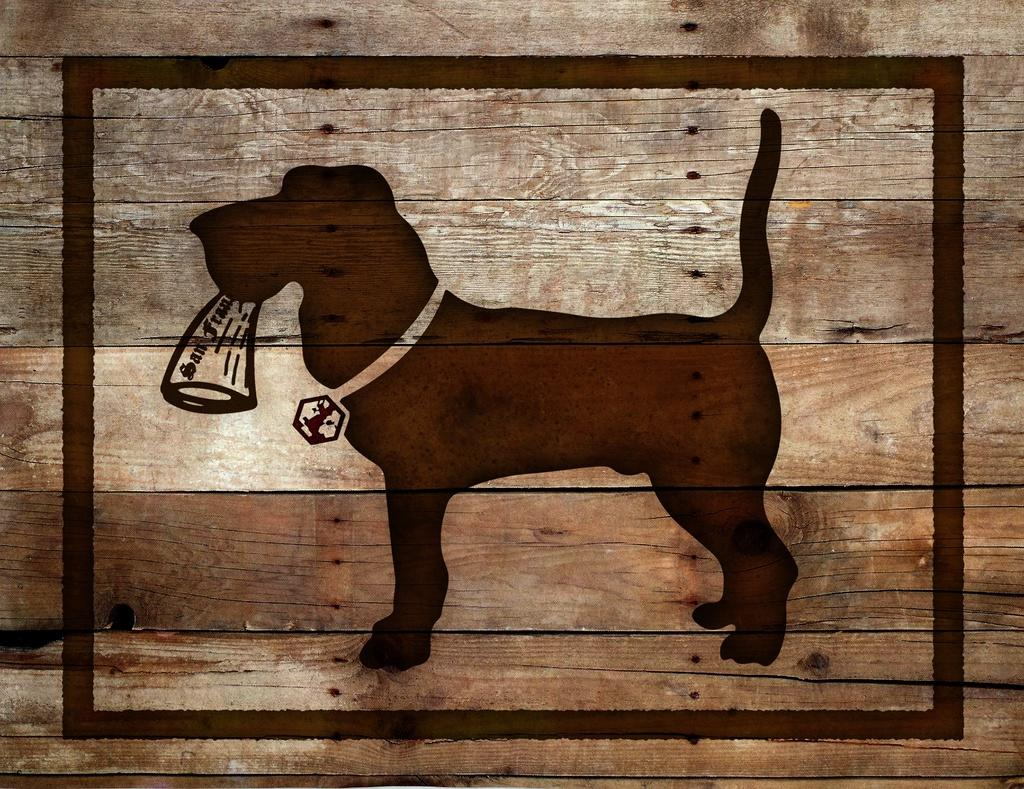What type of wall is depicted in the image? There is a wooden wall in the image. What design can be seen on the wooden wall? There is a dog design on the wooden wall. What is the dog design holding? The dog design appears to be holding something. What accessory is the dog design wearing? The dog design has a belt on its neck. How does the wooden wall feel to the touch in the image? The image does not provide information about the texture or feel of the wooden wall, so it cannot be determined from the image. 